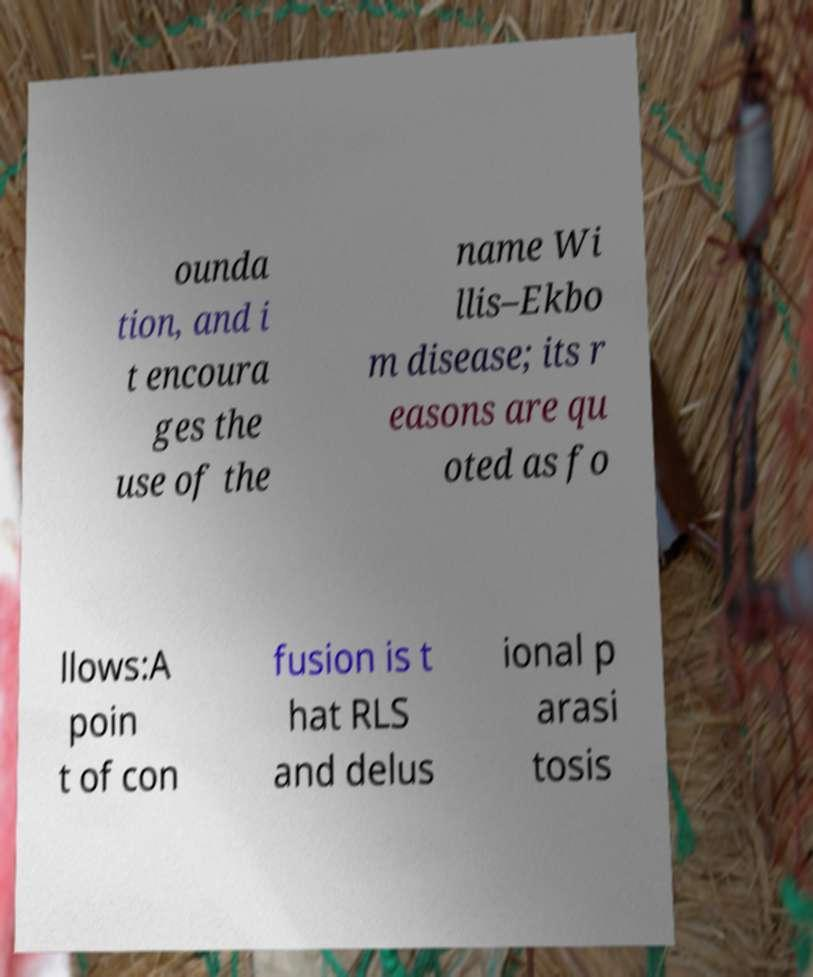Could you extract and type out the text from this image? ounda tion, and i t encoura ges the use of the name Wi llis–Ekbo m disease; its r easons are qu oted as fo llows:A poin t of con fusion is t hat RLS and delus ional p arasi tosis 